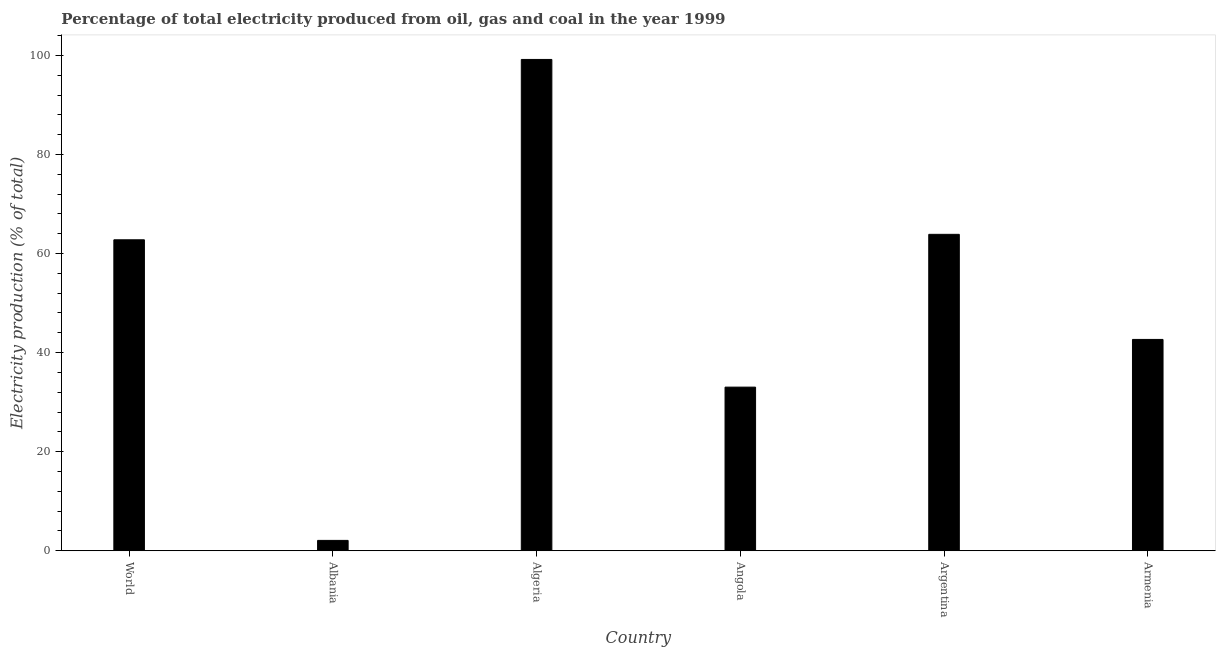Does the graph contain grids?
Your answer should be compact. No. What is the title of the graph?
Offer a very short reply. Percentage of total electricity produced from oil, gas and coal in the year 1999. What is the label or title of the X-axis?
Give a very brief answer. Country. What is the label or title of the Y-axis?
Keep it short and to the point. Electricity production (% of total). What is the electricity production in Argentina?
Your response must be concise. 63.87. Across all countries, what is the maximum electricity production?
Ensure brevity in your answer.  99.18. Across all countries, what is the minimum electricity production?
Give a very brief answer. 2.09. In which country was the electricity production maximum?
Your response must be concise. Algeria. In which country was the electricity production minimum?
Provide a short and direct response. Albania. What is the sum of the electricity production?
Ensure brevity in your answer.  303.62. What is the difference between the electricity production in Albania and Argentina?
Give a very brief answer. -61.78. What is the average electricity production per country?
Provide a short and direct response. 50.6. What is the median electricity production?
Your answer should be very brief. 52.72. In how many countries, is the electricity production greater than 20 %?
Give a very brief answer. 5. What is the ratio of the electricity production in Albania to that in Argentina?
Make the answer very short. 0.03. Is the difference between the electricity production in Argentina and World greater than the difference between any two countries?
Your response must be concise. No. What is the difference between the highest and the second highest electricity production?
Provide a short and direct response. 35.3. What is the difference between the highest and the lowest electricity production?
Offer a very short reply. 97.09. In how many countries, is the electricity production greater than the average electricity production taken over all countries?
Offer a very short reply. 3. How many bars are there?
Offer a very short reply. 6. Are all the bars in the graph horizontal?
Your answer should be very brief. No. What is the difference between two consecutive major ticks on the Y-axis?
Keep it short and to the point. 20. Are the values on the major ticks of Y-axis written in scientific E-notation?
Your response must be concise. No. What is the Electricity production (% of total) of World?
Offer a very short reply. 62.77. What is the Electricity production (% of total) in Albania?
Give a very brief answer. 2.09. What is the Electricity production (% of total) in Algeria?
Make the answer very short. 99.18. What is the Electricity production (% of total) of Angola?
Provide a short and direct response. 33.03. What is the Electricity production (% of total) in Argentina?
Ensure brevity in your answer.  63.87. What is the Electricity production (% of total) in Armenia?
Offer a very short reply. 42.66. What is the difference between the Electricity production (% of total) in World and Albania?
Ensure brevity in your answer.  60.68. What is the difference between the Electricity production (% of total) in World and Algeria?
Keep it short and to the point. -36.41. What is the difference between the Electricity production (% of total) in World and Angola?
Provide a short and direct response. 29.74. What is the difference between the Electricity production (% of total) in World and Argentina?
Ensure brevity in your answer.  -1.1. What is the difference between the Electricity production (% of total) in World and Armenia?
Offer a terse response. 20.11. What is the difference between the Electricity production (% of total) in Albania and Algeria?
Offer a terse response. -97.09. What is the difference between the Electricity production (% of total) in Albania and Angola?
Keep it short and to the point. -30.94. What is the difference between the Electricity production (% of total) in Albania and Argentina?
Make the answer very short. -61.78. What is the difference between the Electricity production (% of total) in Albania and Armenia?
Keep it short and to the point. -40.57. What is the difference between the Electricity production (% of total) in Algeria and Angola?
Offer a terse response. 66.15. What is the difference between the Electricity production (% of total) in Algeria and Argentina?
Offer a very short reply. 35.31. What is the difference between the Electricity production (% of total) in Algeria and Armenia?
Provide a succinct answer. 56.52. What is the difference between the Electricity production (% of total) in Angola and Argentina?
Give a very brief answer. -30.84. What is the difference between the Electricity production (% of total) in Angola and Armenia?
Give a very brief answer. -9.63. What is the difference between the Electricity production (% of total) in Argentina and Armenia?
Your answer should be compact. 21.21. What is the ratio of the Electricity production (% of total) in World to that in Albania?
Your answer should be compact. 29.98. What is the ratio of the Electricity production (% of total) in World to that in Algeria?
Give a very brief answer. 0.63. What is the ratio of the Electricity production (% of total) in World to that in Armenia?
Make the answer very short. 1.47. What is the ratio of the Electricity production (% of total) in Albania to that in Algeria?
Offer a very short reply. 0.02. What is the ratio of the Electricity production (% of total) in Albania to that in Angola?
Keep it short and to the point. 0.06. What is the ratio of the Electricity production (% of total) in Albania to that in Argentina?
Offer a terse response. 0.03. What is the ratio of the Electricity production (% of total) in Albania to that in Armenia?
Provide a succinct answer. 0.05. What is the ratio of the Electricity production (% of total) in Algeria to that in Angola?
Ensure brevity in your answer.  3. What is the ratio of the Electricity production (% of total) in Algeria to that in Argentina?
Keep it short and to the point. 1.55. What is the ratio of the Electricity production (% of total) in Algeria to that in Armenia?
Keep it short and to the point. 2.33. What is the ratio of the Electricity production (% of total) in Angola to that in Argentina?
Make the answer very short. 0.52. What is the ratio of the Electricity production (% of total) in Angola to that in Armenia?
Provide a succinct answer. 0.77. What is the ratio of the Electricity production (% of total) in Argentina to that in Armenia?
Offer a very short reply. 1.5. 